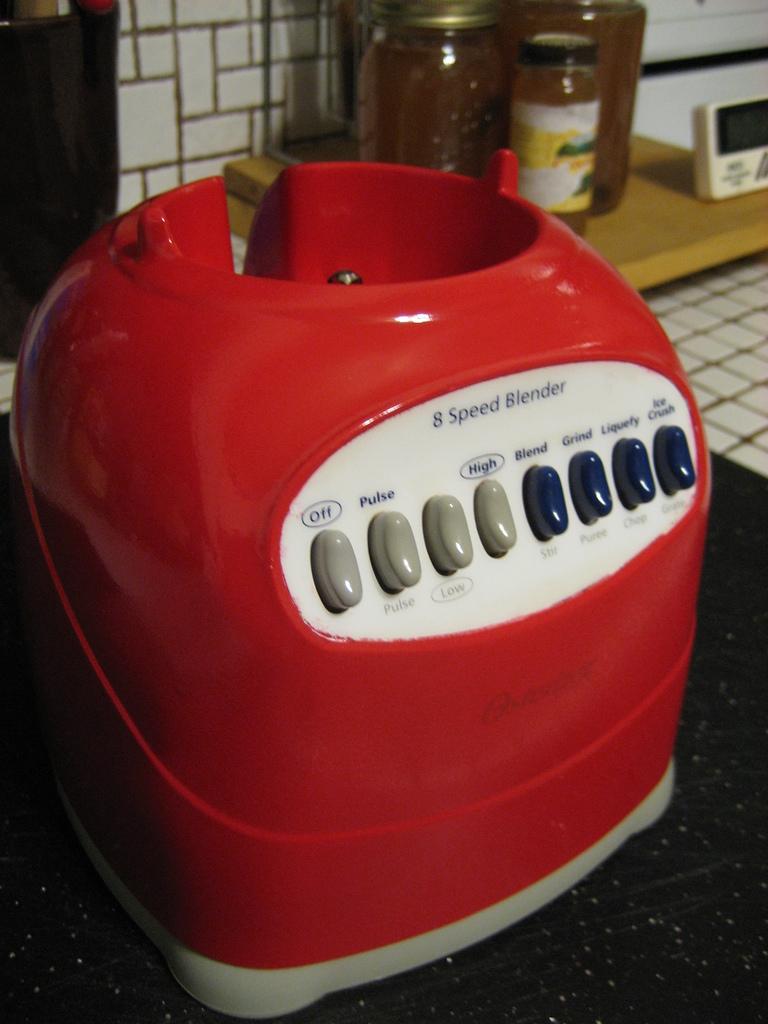Which button turns off the blender?
Ensure brevity in your answer.  The first one. How many speeds does this blender have?
Give a very brief answer. 8. 